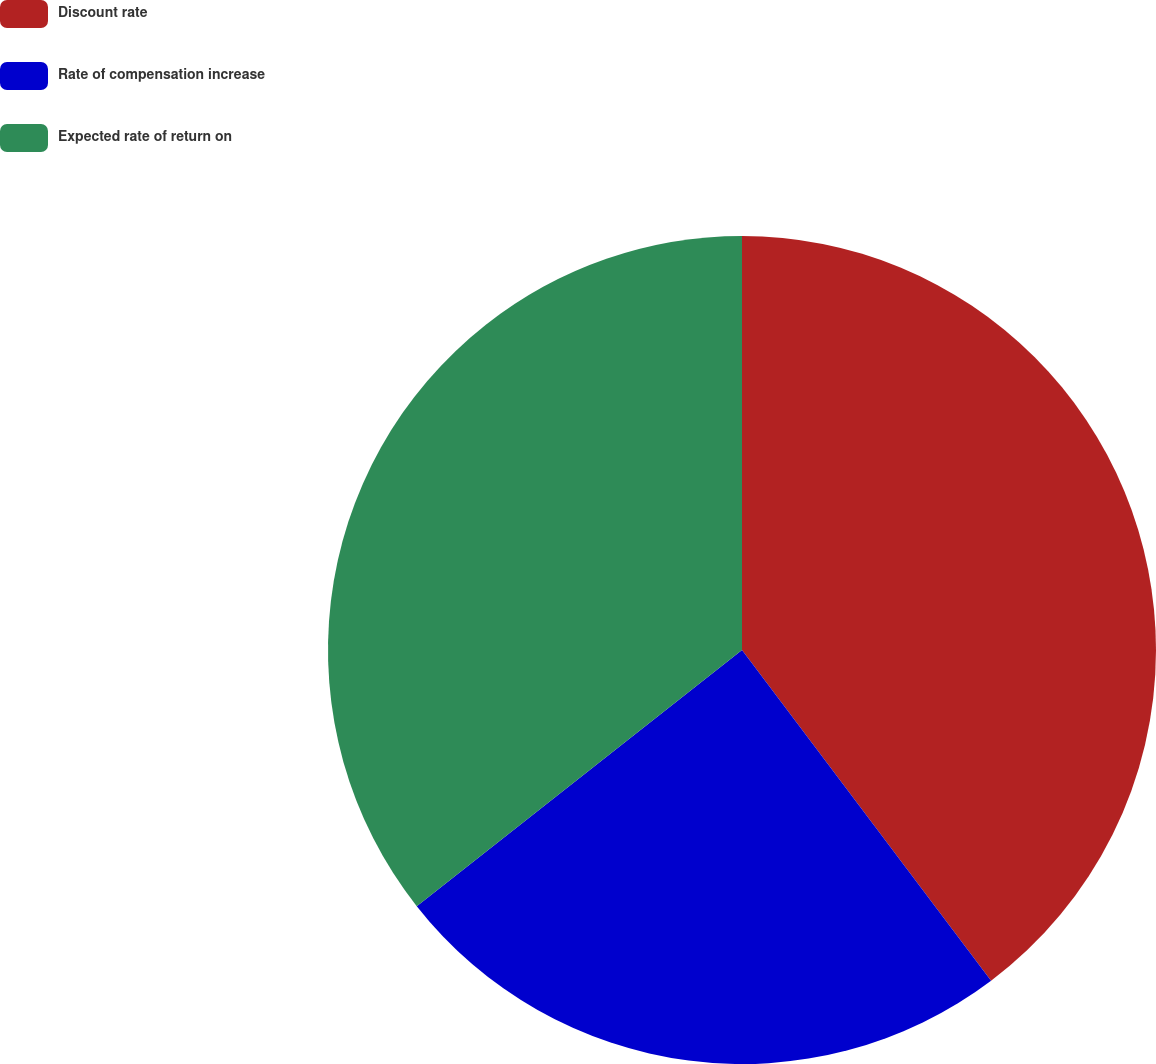Convert chart to OTSL. <chart><loc_0><loc_0><loc_500><loc_500><pie_chart><fcel>Discount rate<fcel>Rate of compensation increase<fcel>Expected rate of return on<nl><fcel>39.73%<fcel>24.66%<fcel>35.62%<nl></chart> 